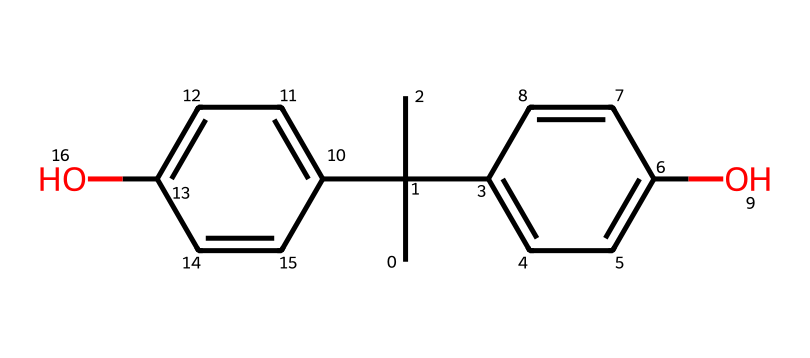What is the molecular formula of bisphenol A? To determine the molecular formula from the SMILES representation, we need to identify the number of each type of atom in the structure. By analyzing the SMILES, we count 15 carbon atoms, 16 hydrogen atoms, and 2 oxygen atoms, leading to the formula C15H16O2.
Answer: C15H16O2 How many hydroxyl (–OH) groups are present in bisphenol A? In the chemical structure, the –OH groups are indicated by the oxygen atoms attached to carbon atoms. From the SMILES, we can see that there are 2 hydroxyl groups, as evidenced by the two 'O' symbols in the representation.
Answer: 2 What type of chemical bonds are most prevalent in bisphenol A? In analyzing the chemical structure, we see a combination of single and double bonds. However, due to the presence of aromatic rings and the representative structure, it is reasonable to conclude that the predominant bonds are covalent, particularly in the aromatic components of the molecule.
Answer: covalent What physical state is bisphenol A at room temperature? Bisphenol A is typically a solid at room temperature, which can be inferred from its molecular structure and properties as a chemical. The arrangement of carbon atoms suggests a stable solid state under standard conditions.
Answer: solid Is bisphenol A classified as an endocrine disruptor? Bisphenol A has been widely studied and recognized for its potential to act as an endocrine disruptor, mainly due to its ability to mimic estrogen and interfere with hormonal functions. This classification is well-documented in environmental and health studies.
Answer: yes How many rings are there in the structure of bisphenol A? Looking at the SMILES structure, we observe two distinct aromatic rings. Each ring is formed by a set of carbon atoms that create a cyclic structure, confirming that there are a total of 2 rings in bisphenol A.
Answer: 2 